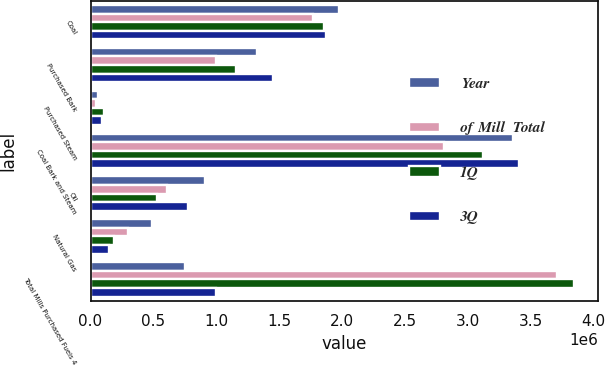<chart> <loc_0><loc_0><loc_500><loc_500><stacked_bar_chart><ecel><fcel>Coal<fcel>Purchased Bark<fcel>Purchased Steam<fcel>Coal Bark and Steam<fcel>Oil<fcel>Natural Gas<fcel>Total Mills Purchased Fuels 4<nl><fcel>Year<fcel>1.97643e+06<fcel>1.32301e+06<fcel>59122<fcel>3.35856e+06<fcel>907461<fcel>487320<fcel>753346<nl><fcel>of Mill  Total<fcel>1.76718e+06<fcel>995182<fcel>46427<fcel>2.80878e+06<fcel>609744<fcel>295393<fcel>3.71392e+06<nl><fcel>1Q<fcel>1.85703e+06<fcel>1.15864e+06<fcel>105705<fcel>3.12138e+06<fcel>532313<fcel>189402<fcel>3.84309e+06<nl><fcel>3Q<fcel>1.87422e+06<fcel>1.44776e+06<fcel>87655<fcel>3.40963e+06<fcel>771740<fcel>143890<fcel>995182<nl></chart> 